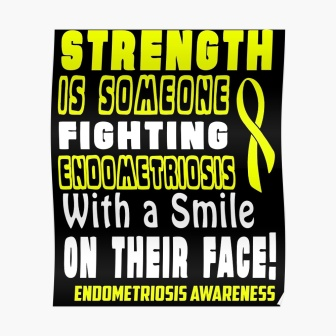Can you imagine a supportive quote that would fit well on this poster? Absolutely. How about: 'Healing takes time, but your strength today will pave the way for a brighter tomorrow.' 